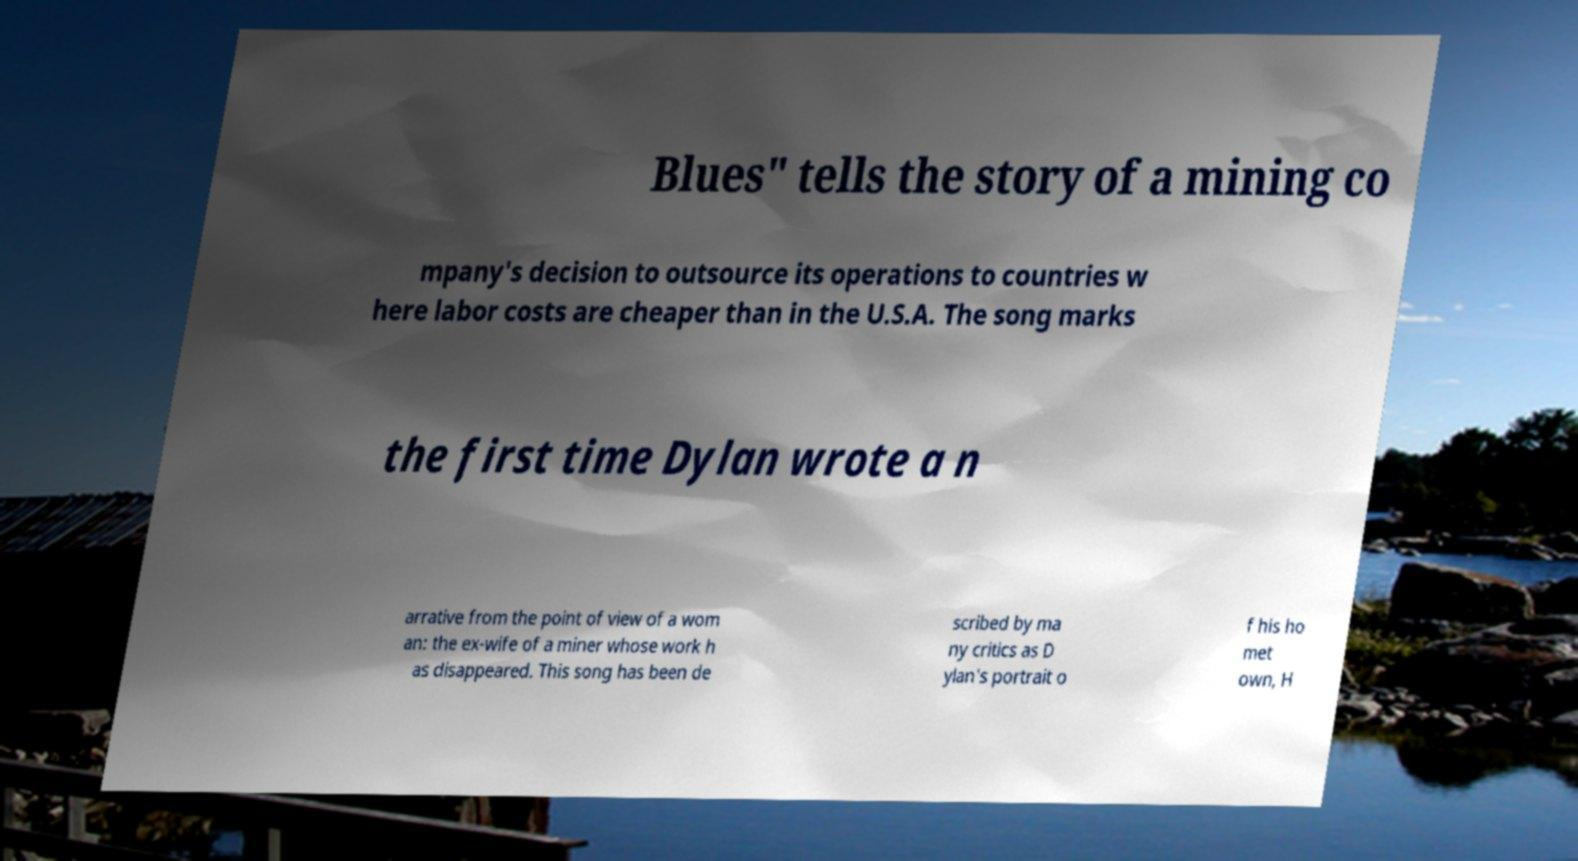Could you assist in decoding the text presented in this image and type it out clearly? Blues" tells the story of a mining co mpany's decision to outsource its operations to countries w here labor costs are cheaper than in the U.S.A. The song marks the first time Dylan wrote a n arrative from the point of view of a wom an: the ex-wife of a miner whose work h as disappeared. This song has been de scribed by ma ny critics as D ylan's portrait o f his ho met own, H 